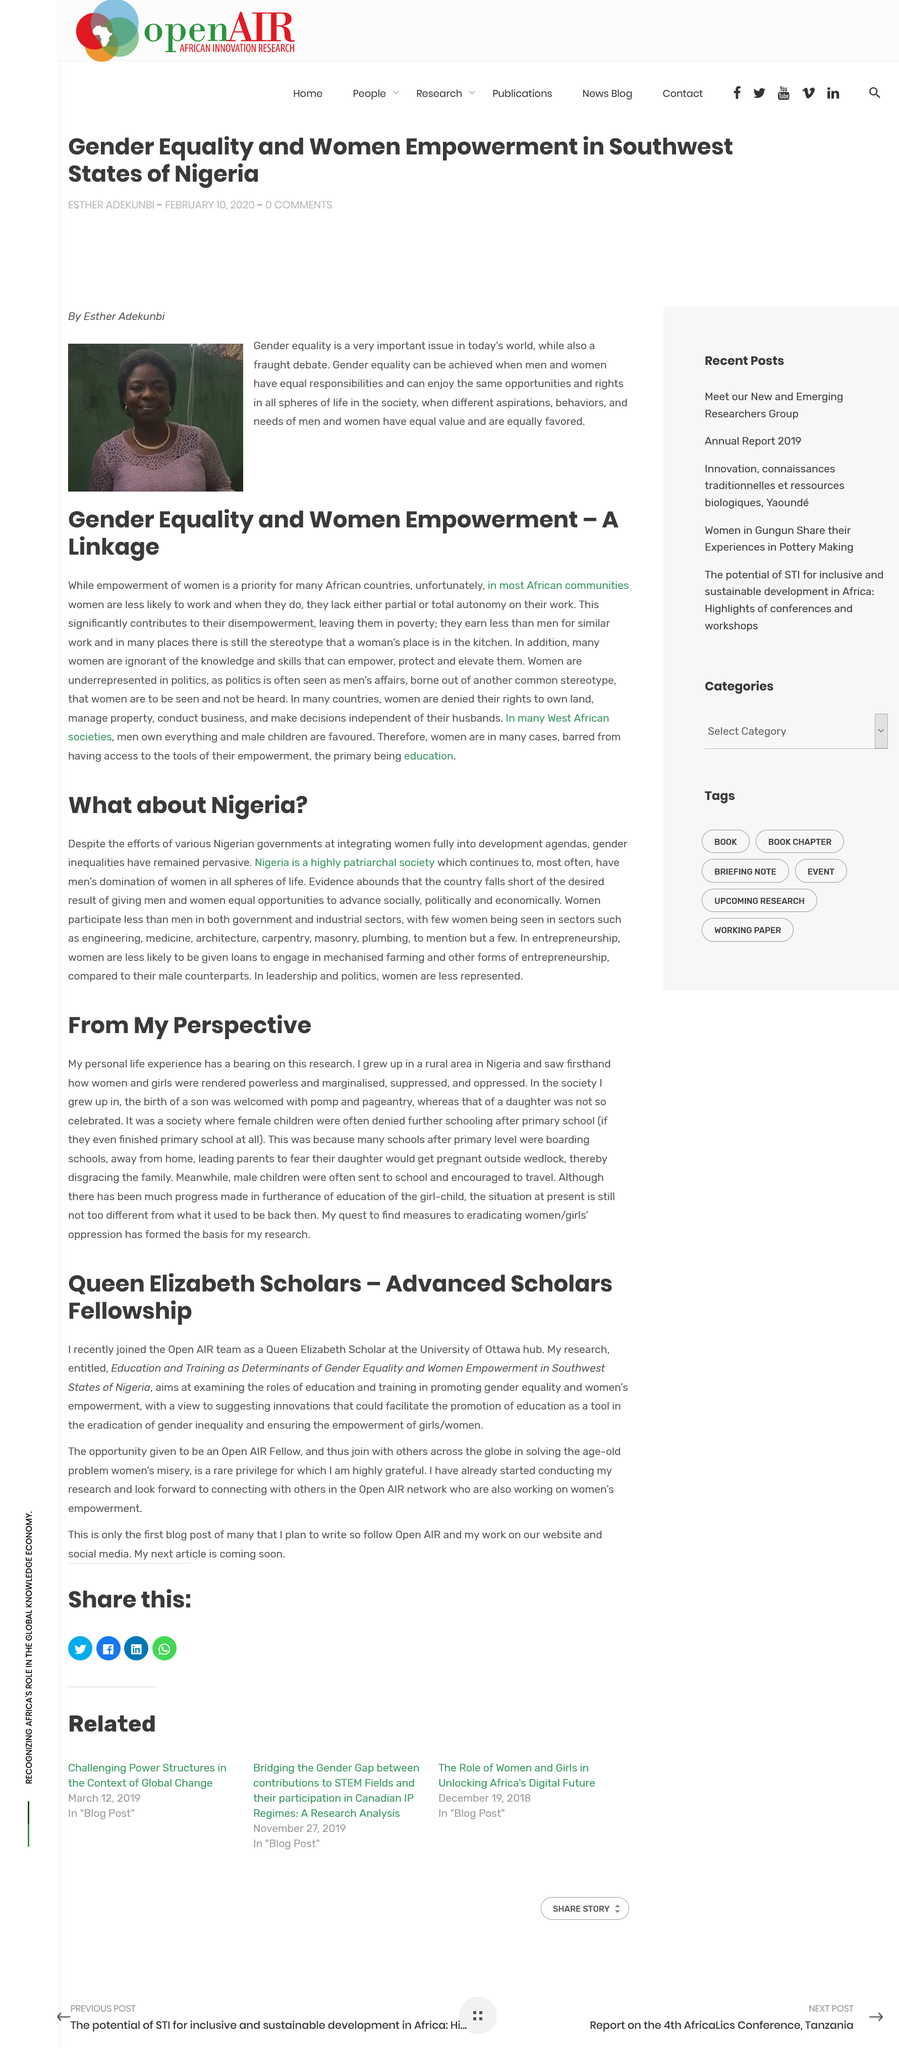Highlight a few significant elements in this photo. The University of Ottawa is referred to as Queen Elizabeth Scholars - Advanced Scholars Fellowship. This article pertains to the country of Nigeria. The research was titled "Education and Training as Determinants of Gender Equality and Women Empowerment in Southwest States of Nigeria. Nigeria is a highly patriarchal society, where men hold significant power and influence over women and girls. The quest to find measures to eradicate women and girls' oppression has served as the foundation of this research. 